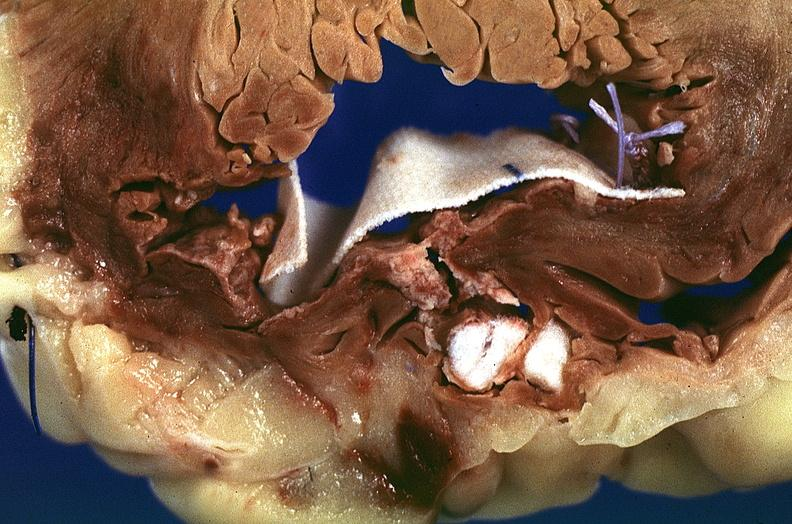s carcinomatosis present?
Answer the question using a single word or phrase. No 